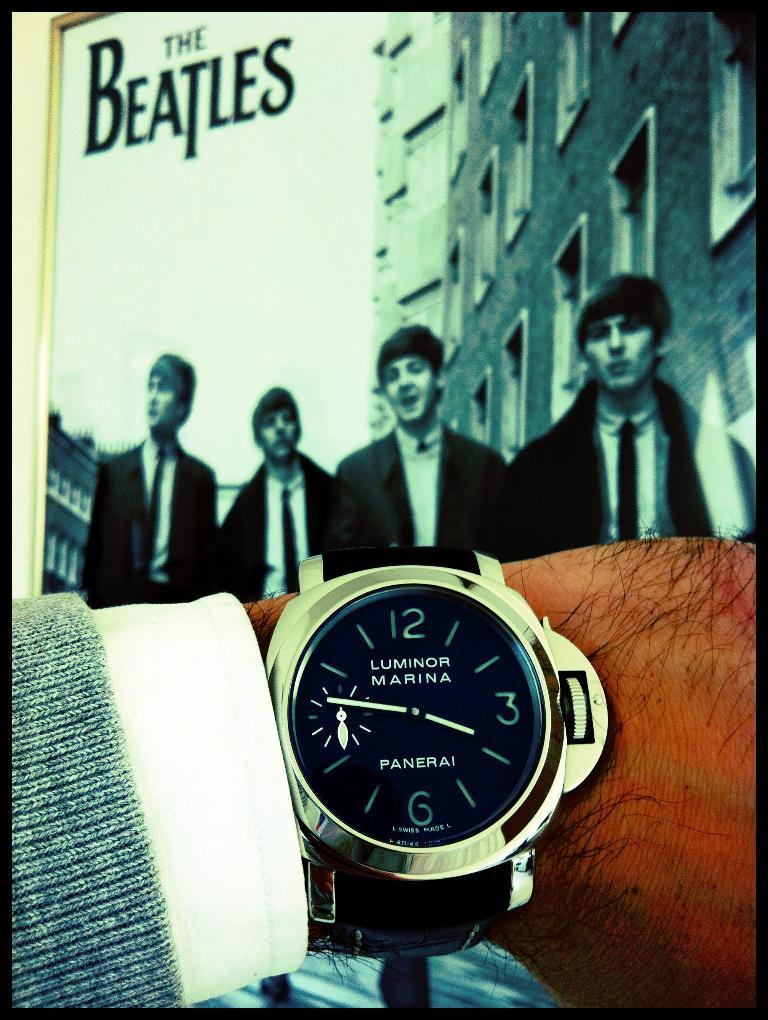<image>
Share a concise interpretation of the image provided. A poster of the Beatles can be seen in front of a mans wrist, who is wearing a Panerai Luminor wrist watch. 